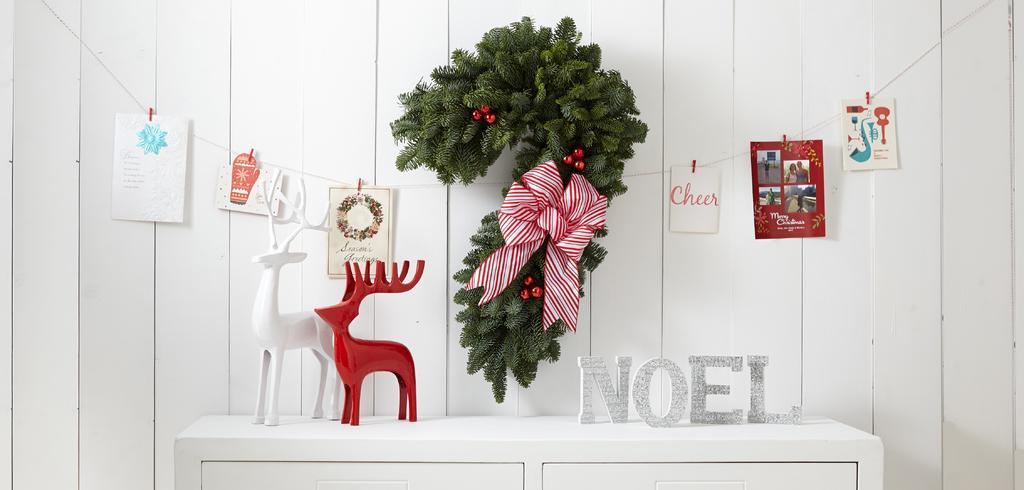Can you describe this image briefly? In the center of the image we can see one table and cupboards. On the table, we can see deer toys, which are in red and white color. And we can see some letters. In the background there is a wall. On the wall, we can see one plant garland, posters tied with thread. And we can see one ribbon on the garland. And we can see some text on the posters. 